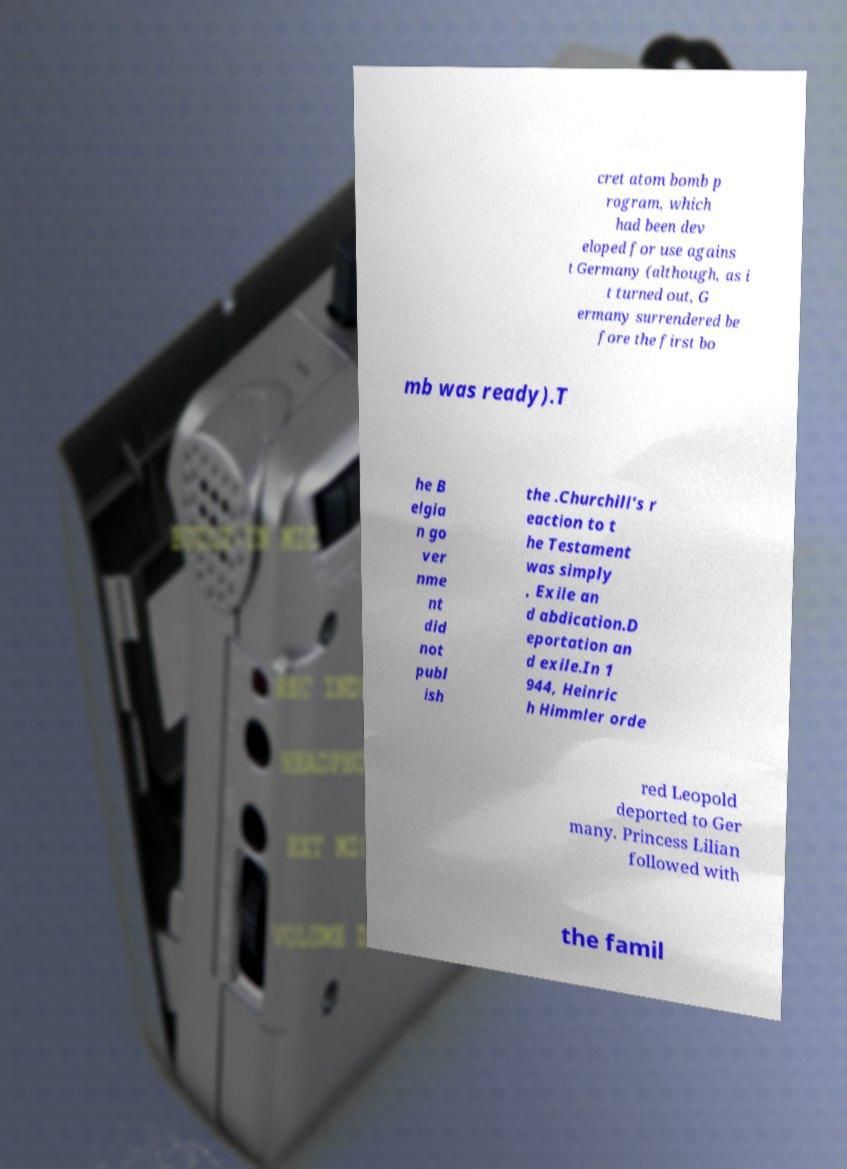Please identify and transcribe the text found in this image. cret atom bomb p rogram, which had been dev eloped for use agains t Germany (although, as i t turned out, G ermany surrendered be fore the first bo mb was ready).T he B elgia n go ver nme nt did not publ ish the .Churchill's r eaction to t he Testament was simply , Exile an d abdication.D eportation an d exile.In 1 944, Heinric h Himmler orde red Leopold deported to Ger many. Princess Lilian followed with the famil 